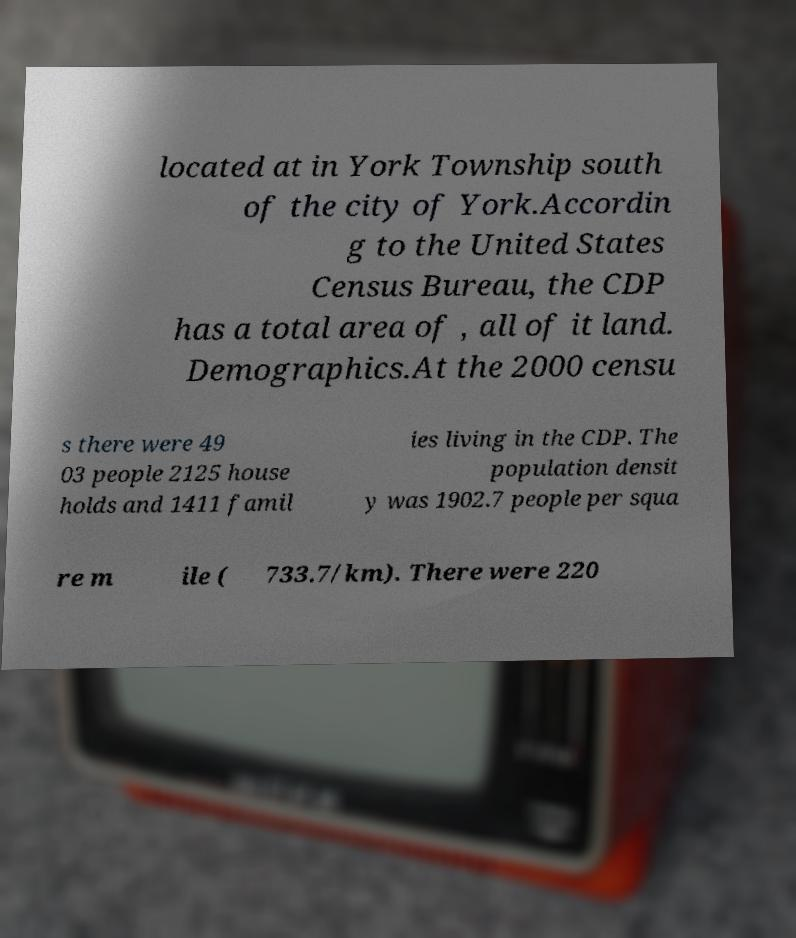Can you accurately transcribe the text from the provided image for me? located at in York Township south of the city of York.Accordin g to the United States Census Bureau, the CDP has a total area of , all of it land. Demographics.At the 2000 censu s there were 49 03 people 2125 house holds and 1411 famil ies living in the CDP. The population densit y was 1902.7 people per squa re m ile ( 733.7/km). There were 220 